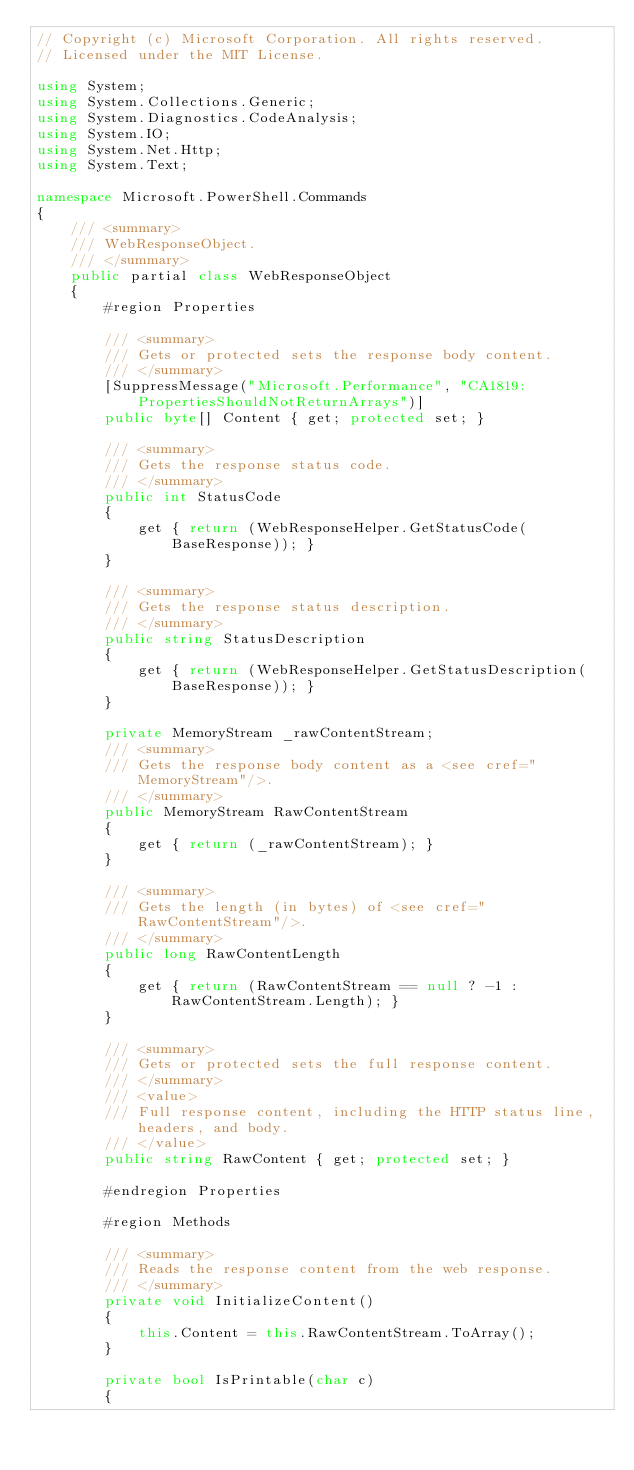Convert code to text. <code><loc_0><loc_0><loc_500><loc_500><_C#_>// Copyright (c) Microsoft Corporation. All rights reserved.
// Licensed under the MIT License.

using System;
using System.Collections.Generic;
using System.Diagnostics.CodeAnalysis;
using System.IO;
using System.Net.Http;
using System.Text;

namespace Microsoft.PowerShell.Commands
{
    /// <summary>
    /// WebResponseObject.
    /// </summary>
    public partial class WebResponseObject
    {
        #region Properties

        /// <summary>
        /// Gets or protected sets the response body content.
        /// </summary>
        [SuppressMessage("Microsoft.Performance", "CA1819:PropertiesShouldNotReturnArrays")]
        public byte[] Content { get; protected set; }

        /// <summary>
        /// Gets the response status code.
        /// </summary>
        public int StatusCode
        {
            get { return (WebResponseHelper.GetStatusCode(BaseResponse)); }
        }

        /// <summary>
        /// Gets the response status description.
        /// </summary>
        public string StatusDescription
        {
            get { return (WebResponseHelper.GetStatusDescription(BaseResponse)); }
        }

        private MemoryStream _rawContentStream;
        /// <summary>
        /// Gets the response body content as a <see cref="MemoryStream"/>.
        /// </summary>
        public MemoryStream RawContentStream
        {
            get { return (_rawContentStream); }
        }

        /// <summary>
        /// Gets the length (in bytes) of <see cref="RawContentStream"/>.
        /// </summary>
        public long RawContentLength
        {
            get { return (RawContentStream == null ? -1 : RawContentStream.Length); }
        }

        /// <summary>
        /// Gets or protected sets the full response content.
        /// </summary>
        /// <value>
        /// Full response content, including the HTTP status line, headers, and body.
        /// </value>
        public string RawContent { get; protected set; }

        #endregion Properties

        #region Methods

        /// <summary>
        /// Reads the response content from the web response.
        /// </summary>
        private void InitializeContent()
        {
            this.Content = this.RawContentStream.ToArray();
        }

        private bool IsPrintable(char c)
        {</code> 